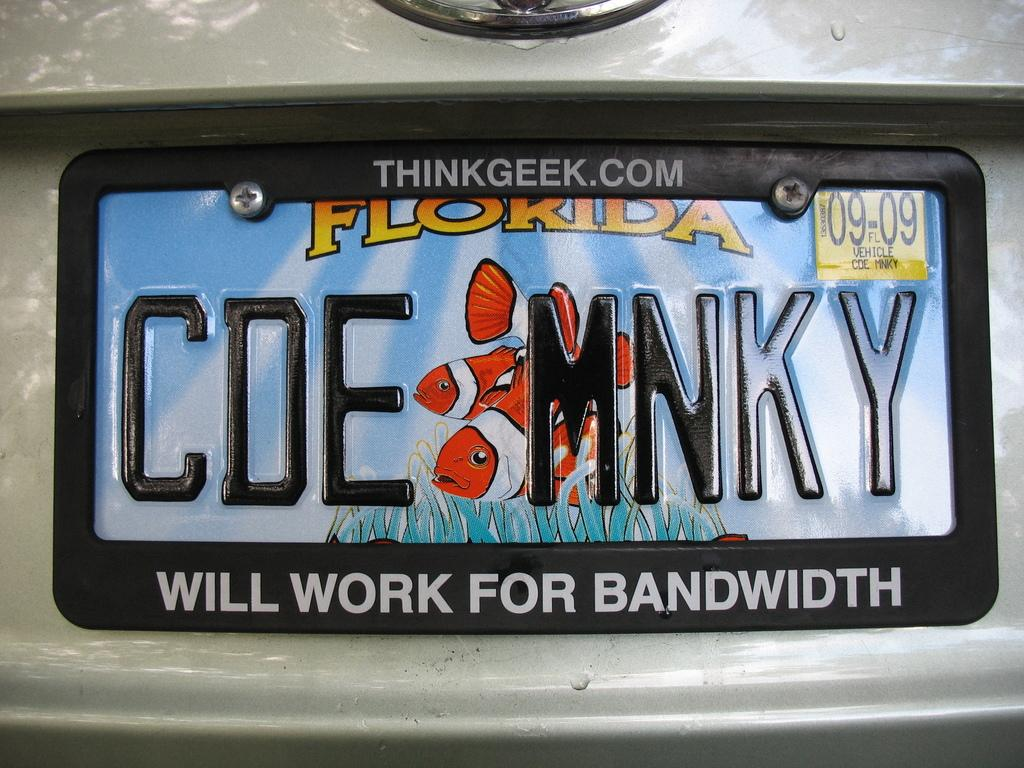<image>
Present a compact description of the photo's key features. A Florida license plate is attached to the back of a car. 